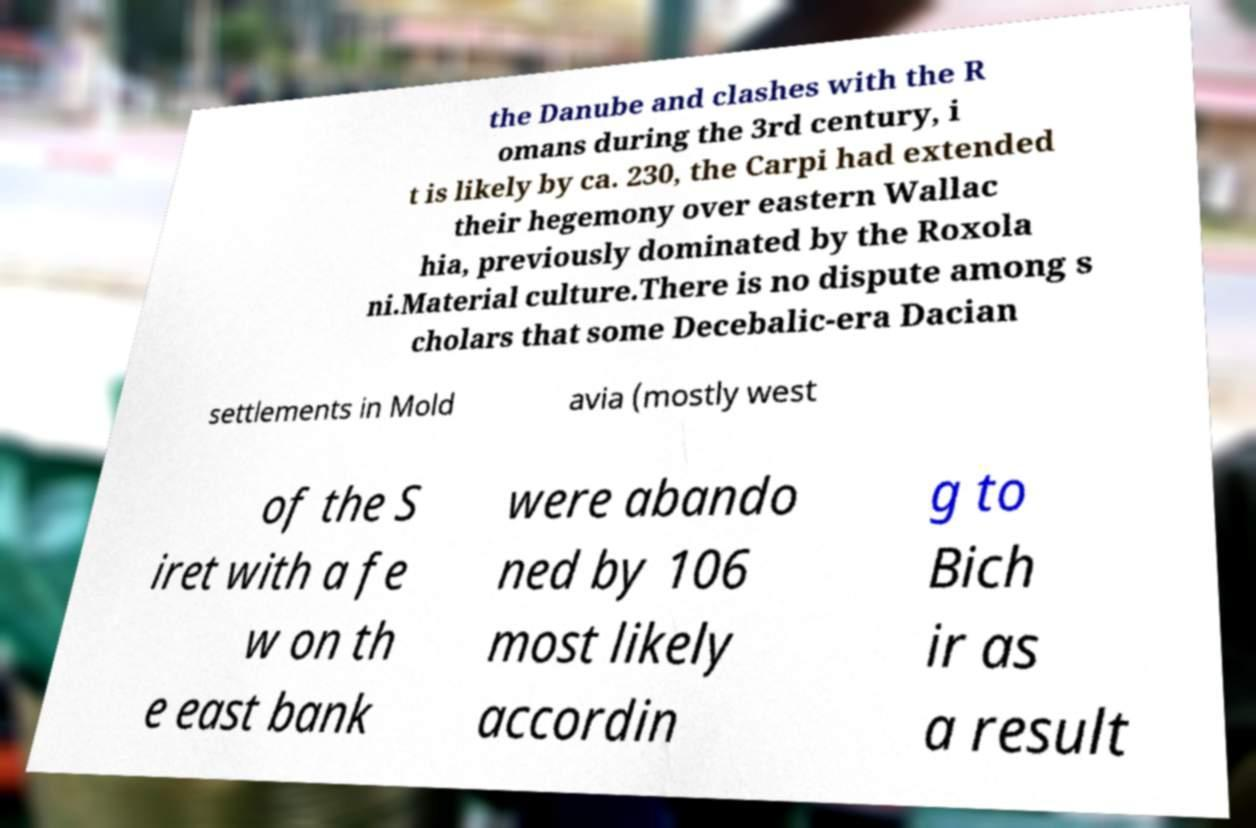For documentation purposes, I need the text within this image transcribed. Could you provide that? the Danube and clashes with the R omans during the 3rd century, i t is likely by ca. 230, the Carpi had extended their hegemony over eastern Wallac hia, previously dominated by the Roxola ni.Material culture.There is no dispute among s cholars that some Decebalic-era Dacian settlements in Mold avia (mostly west of the S iret with a fe w on th e east bank were abando ned by 106 most likely accordin g to Bich ir as a result 